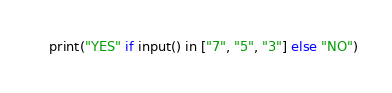<code> <loc_0><loc_0><loc_500><loc_500><_Python_>print("YES" if input() in ["7", "5", "3"] else "NO")</code> 